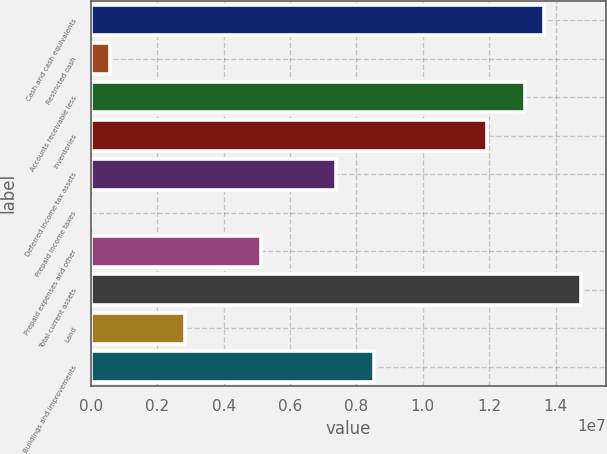Convert chart. <chart><loc_0><loc_0><loc_500><loc_500><bar_chart><fcel>Cash and cash equivalents<fcel>Restricted cash<fcel>Accounts receivable less<fcel>Inventories<fcel>Deferred income tax assets<fcel>Prepaid income taxes<fcel>Prepaid expenses and other<fcel>Total current assets<fcel>Land<fcel>Buildings and improvements<nl><fcel>1.36419e+07<fcel>568577<fcel>1.30735e+07<fcel>1.19367e+07<fcel>7.38944e+06<fcel>172<fcel>5.11582e+06<fcel>1.47787e+07<fcel>2.8422e+06<fcel>8.52625e+06<nl></chart> 